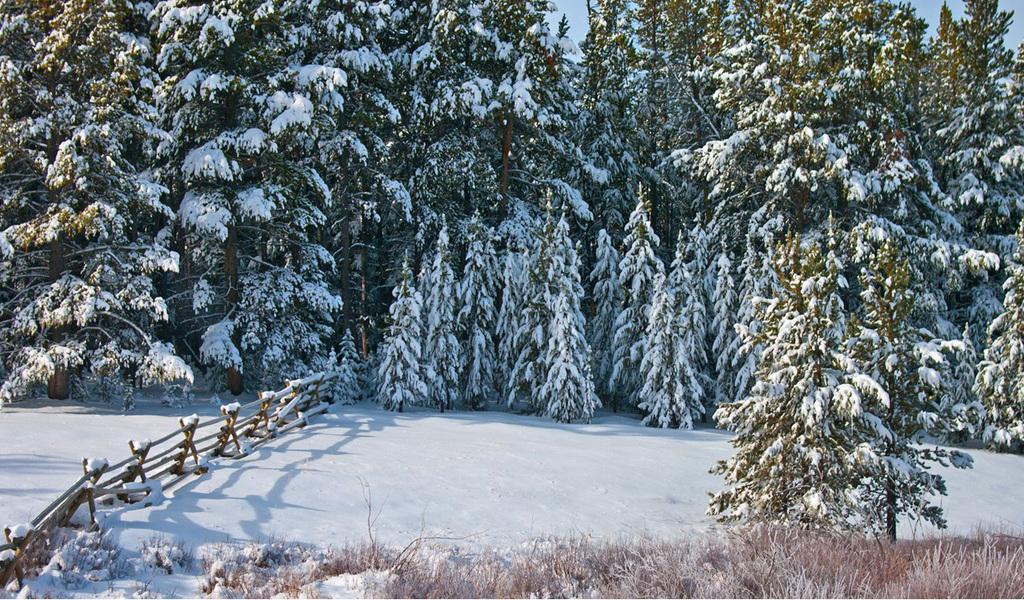What type of natural elements are present in the image? The image contains many trees and plants. How are the trees and plants in the image affected by the weather? The trees and plants are covered with snow. What is visible at the bottom of the image? There is snow at the bottom of the image. What type of barrier can be seen on the left side of the image? There is a wooden fencing on the left side of the image. Who is the owner of the balance in the image? There is no balance present in the image. 